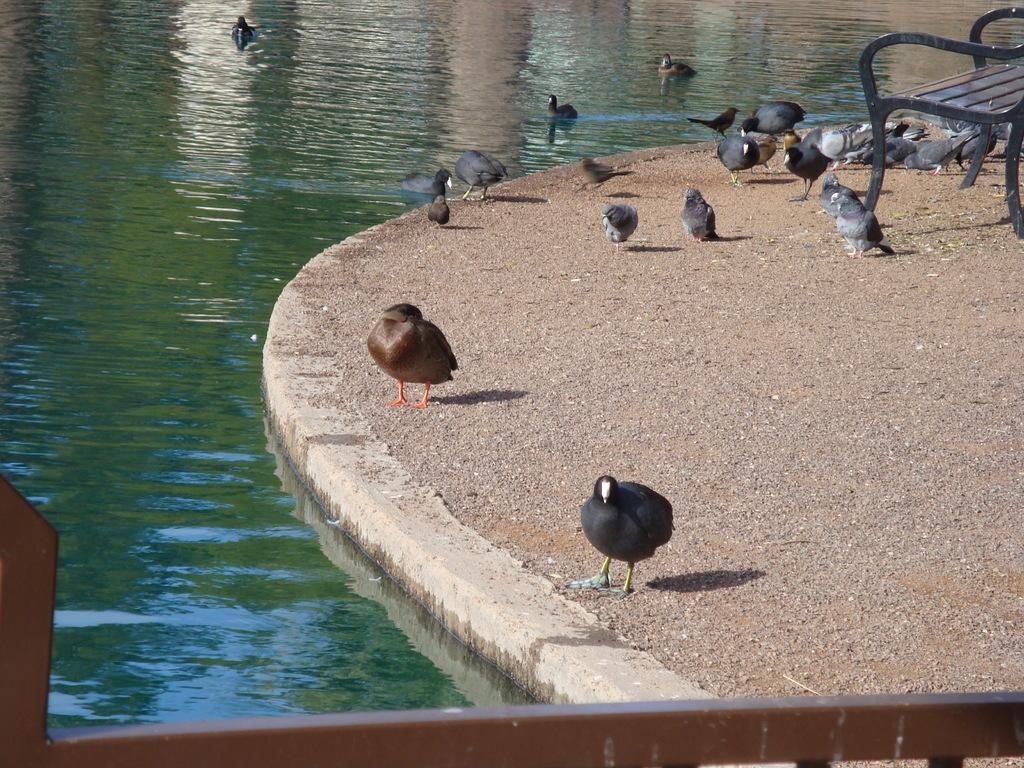Please provide a concise description of this image. In this image we can see a group of birds and a bench on the ground. We can also see a metal pole and some birds in a water body. 